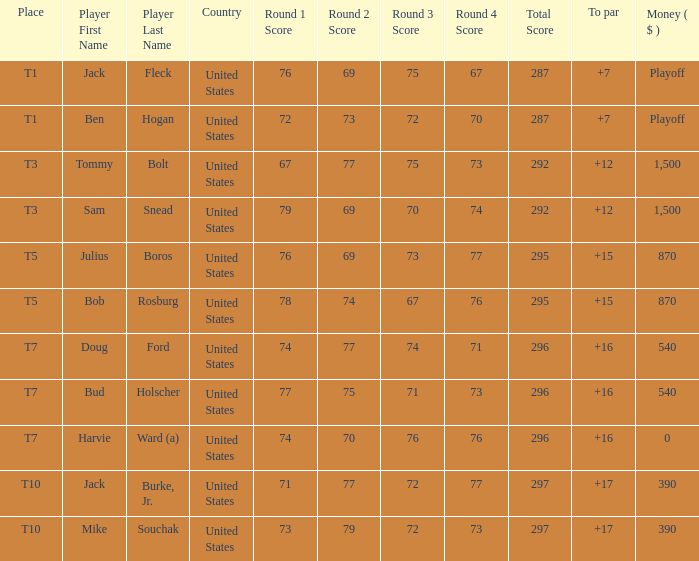What is the total of all to par with player Bob Rosburg? 15.0. 